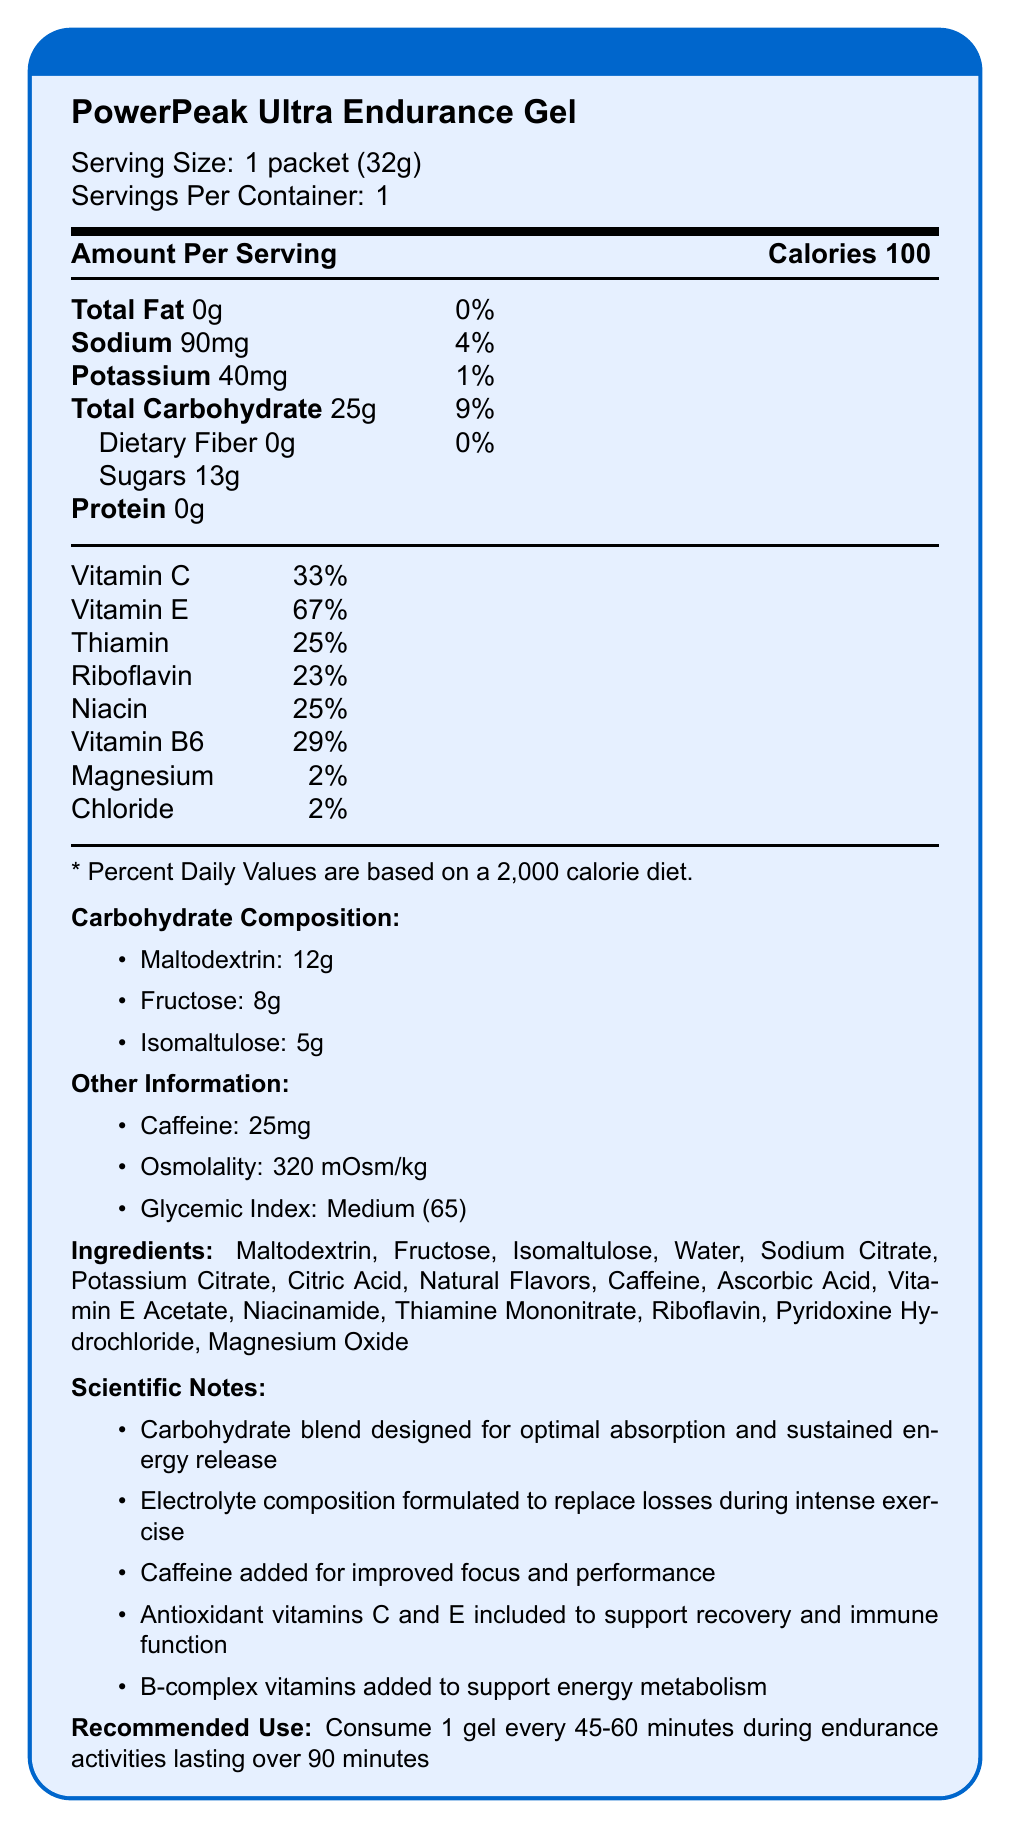What is the serving size of the PowerPeak Ultra Endurance Gel? The document states that the serving size is 1 packet (32g).
Answer: 1 packet (32g) How many grams of Maltodextrin are there in the gel? The document lists Maltodextrin as one of the carbohydrate components with an amount of 12g.
Answer: 12g What is the daily value percentage of Vitamin C provided by the gel? According to the label, the gel provides 33% of the daily value of Vitamin C.
Answer: 33% What is the sodium content in one serving of the gel? The label specifies that one serving contains 90mg of sodium.
Answer: 90mg How much caffeine is included in a single serving? The gel contains 25mg of caffeine per serving, as noted in the "Other Information" section.
Answer: 25mg Which of the following is not an ingredient in the PowerPeak Ultra Endurance Gel? A. Maltodextrin B. Fructose C. Sucrose D. Isomaltulose The list of ingredients does not include Sucrose.
Answer: C. Sucrose Which carbohydrate in the gel has the lowest amount per serving? A. Maltodextrin B. Fructose C. Isomaltulose Isomaltulose has the lowest content at 5g per serving, compared to Maltodextrin (12g) and Fructose (8g).
Answer: C. Isomaltulose Is there any dietary fiber in the PowerPeak Ultra Endurance Gel? The label indicates that the gel contains 0g of dietary fiber.
Answer: No Summarize the main idea of the document. The main idea of the document is to inform users about the nutritional content and benefits of the PowerPeak Ultra Endurance Gel, emphasizing its suitability for endurance activities through its carbohydrate blend, electrolytes, and other performance-enhancing ingredients.
Answer: The document provides comprehensive nutrition facts for the PowerPeak Ultra Endurance Gel, detailing its contents, including calories, carbohydrate types, electrolytes, vitamins, and caffeine. It also includes extra information about its ingredients, scientific notes, and recommended use. How does the electrolyte composition of the gel support its intended use during intense exercise? The scientific notes explain that the electrolytes (sodium and potassium) are formulated to replace losses that occur during intense exercise.
Answer: The electrolyte composition replaces losses during intense exercise. What is the osmolality value of the gel? The other information section specifies that the osmolality is 320 mOsm/kg.
Answer: 320 mOsm/kg Can we determine from the document whether the gel is gluten-free? The document does not provide information regarding whether the gel is gluten-free.
Answer: Not enough information 